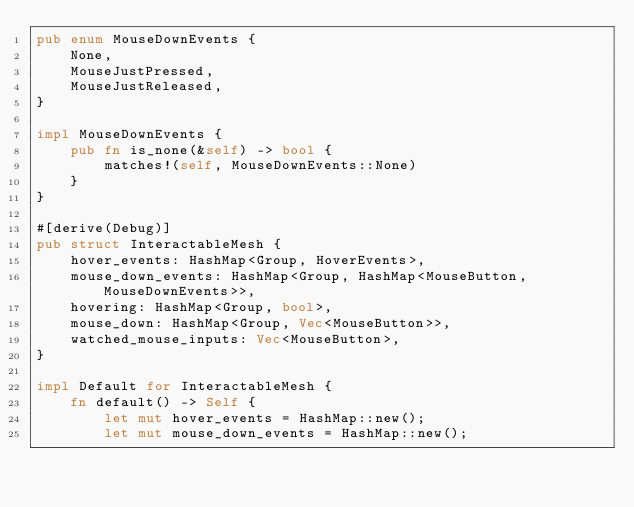<code> <loc_0><loc_0><loc_500><loc_500><_Rust_>pub enum MouseDownEvents {
    None,
    MouseJustPressed,
    MouseJustReleased,
}

impl MouseDownEvents {
    pub fn is_none(&self) -> bool {
        matches!(self, MouseDownEvents::None)
    }
}

#[derive(Debug)]
pub struct InteractableMesh {
    hover_events: HashMap<Group, HoverEvents>,
    mouse_down_events: HashMap<Group, HashMap<MouseButton, MouseDownEvents>>,
    hovering: HashMap<Group, bool>,
    mouse_down: HashMap<Group, Vec<MouseButton>>,
    watched_mouse_inputs: Vec<MouseButton>,
}

impl Default for InteractableMesh {
    fn default() -> Self {
        let mut hover_events = HashMap::new();
        let mut mouse_down_events = HashMap::new();</code> 